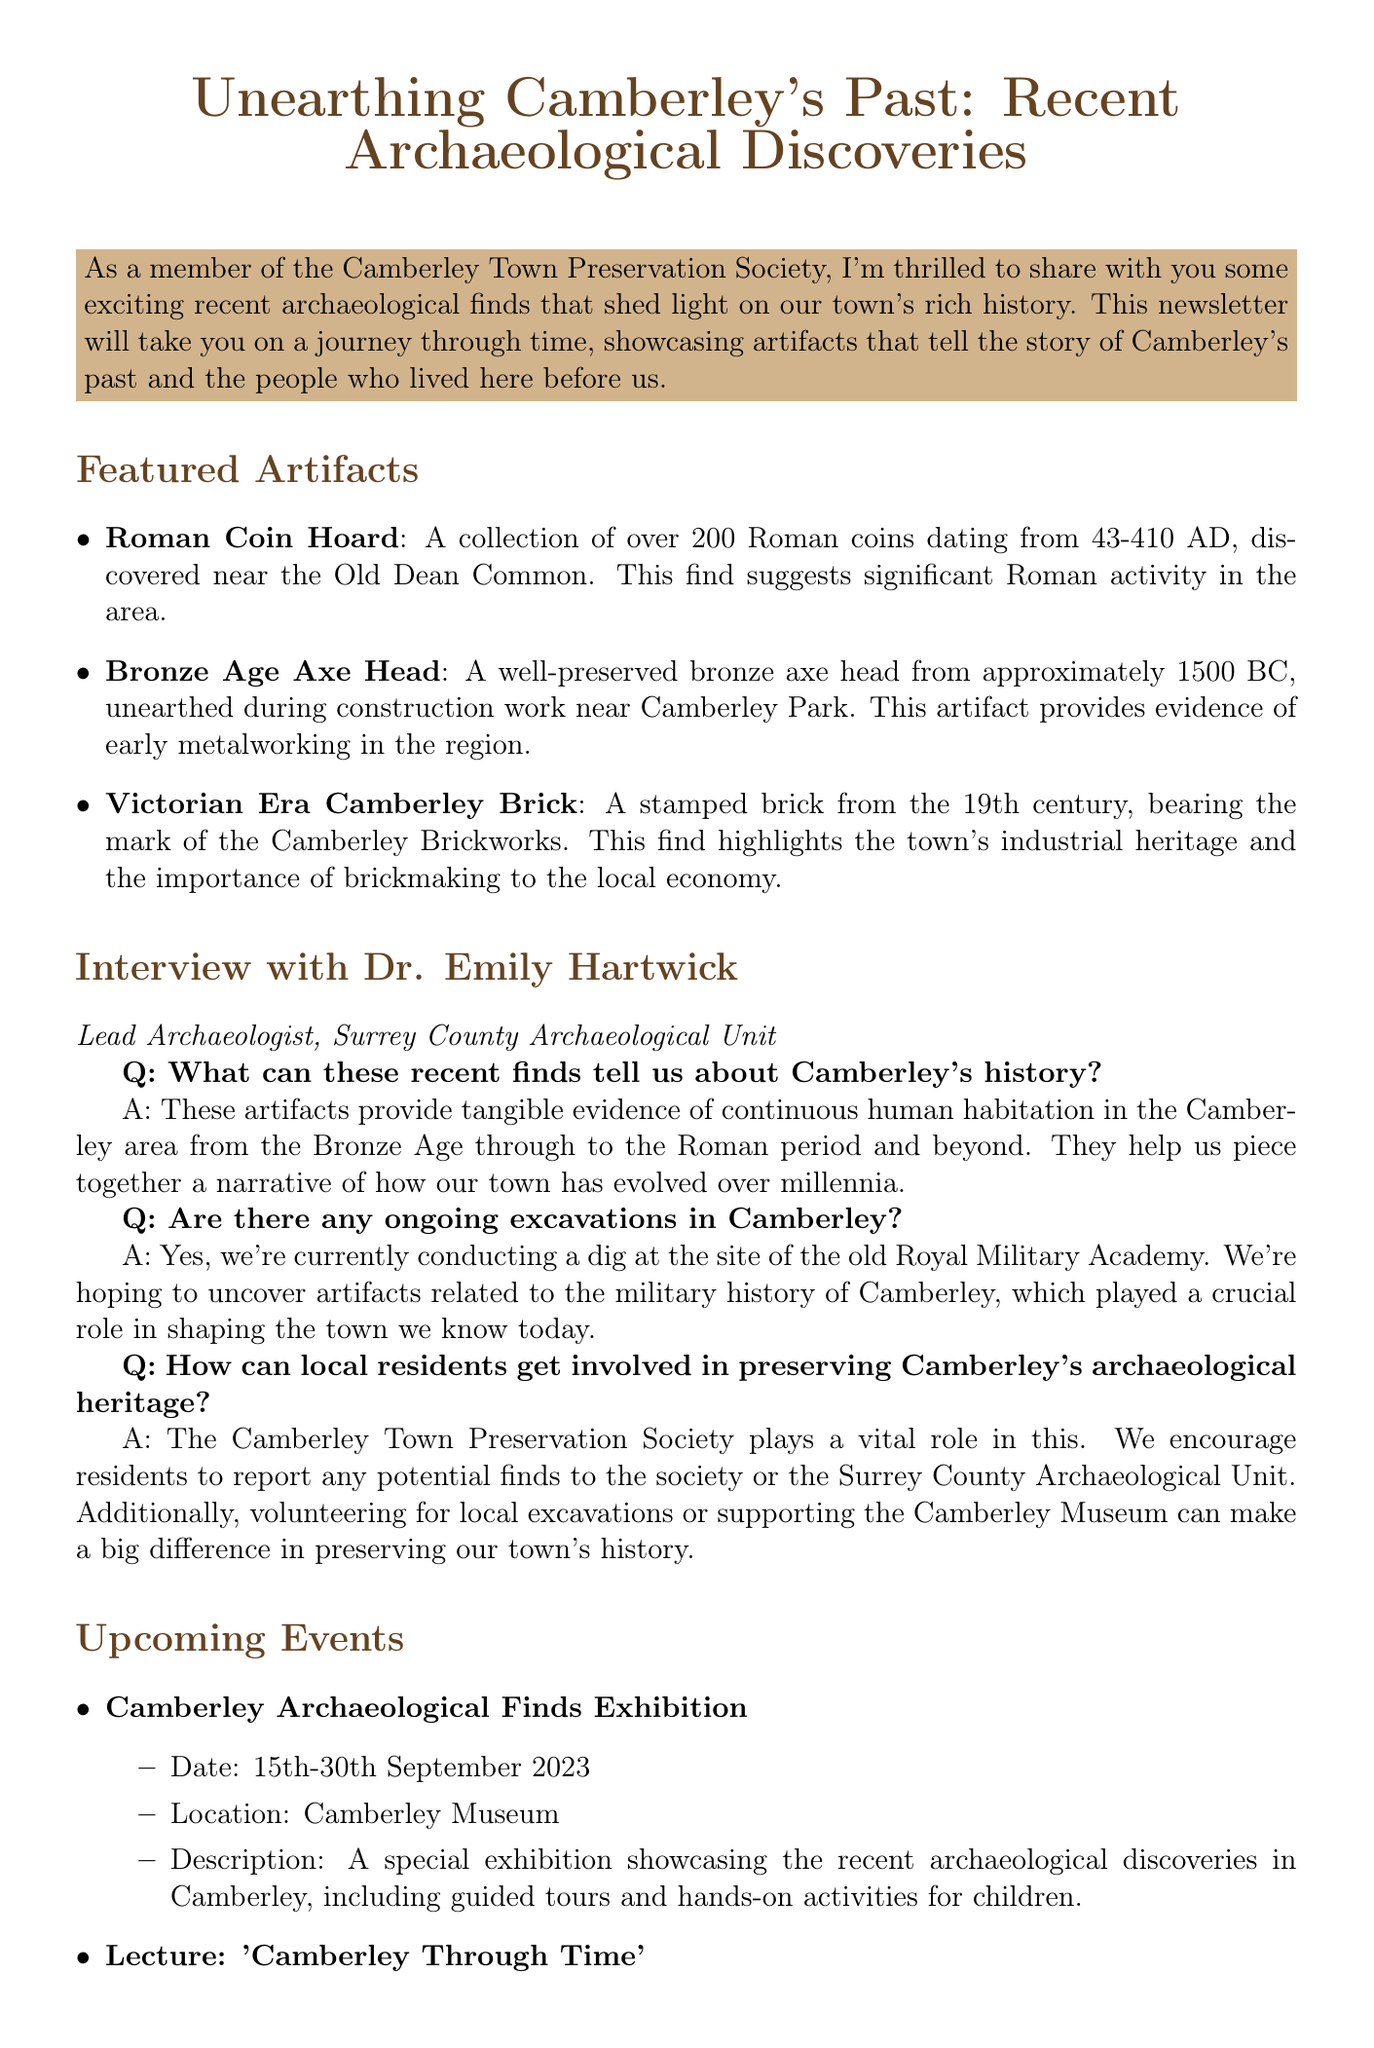What discovery suggests significant Roman activity in Camberley? The document states that the Roman Coin Hoard, a collection of over 200 Roman coins, indicates significant Roman activity in the area.
Answer: Roman Coin Hoard What is the date range of the Roman coins found? The document mentions that the Roman coins date from 43-410 AD.
Answer: 43-410 AD Who is the lead archaeologist interviewed in the newsletter? The document identifies Dr. Emily Hartwick as the Lead Archaeologist from the Surrey County Archaeological Unit.
Answer: Dr. Emily Hartwick What event will Dr. Emily Hartwick present a lecture on? The upcoming lecture mentioned in the document is titled "Camberley Through Time," which will cover the archaeological history of Camberley.
Answer: Camberley Through Time How many artifacts are listed in the featured artifacts section? The document lists a total of three artifacts in the featured artifacts section.
Answer: 3 Where is the Camberley Archaeological Finds Exhibition being held? The document specifies that the exhibition will be held at the Camberley Museum.
Answer: Camberley Museum What type of object is the Bronze Age Axe Head? The document describes it as a well-preserved bronze axe head.
Answer: bronze axe head What does the Victorian Era Camberley Brick highlight about the town? The document mentions that this artifact highlights the town's industrial heritage and the importance of brickmaking to the local economy.
Answer: industrial heritage 